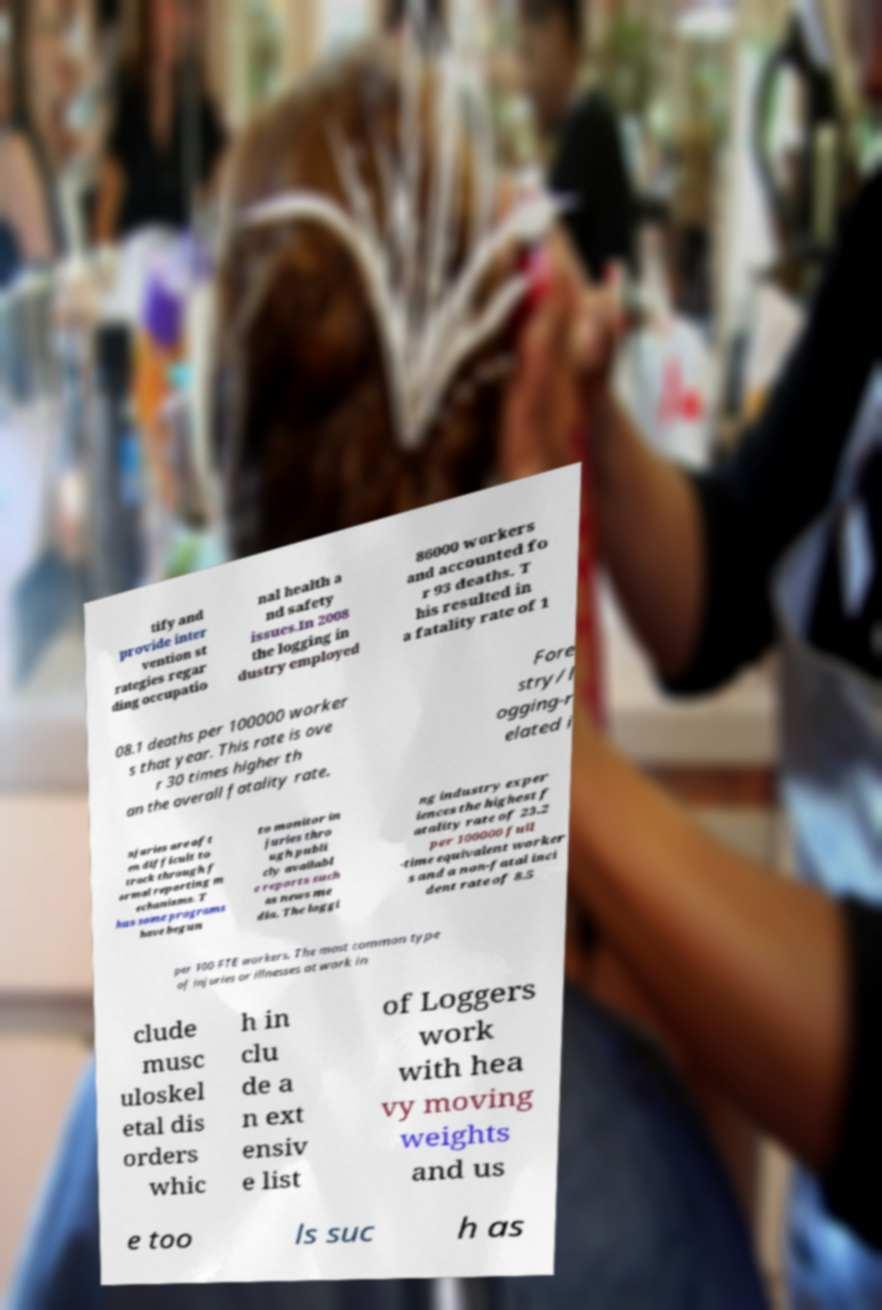There's text embedded in this image that I need extracted. Can you transcribe it verbatim? tify and provide inter vention st rategies regar ding occupatio nal health a nd safety issues.In 2008 the logging in dustry employed 86000 workers and accounted fo r 93 deaths. T his resulted in a fatality rate of 1 08.1 deaths per 100000 worker s that year. This rate is ove r 30 times higher th an the overall fatality rate. Fore stry/l ogging-r elated i njuries are oft en difficult to track through f ormal reporting m echanisms. T hus some programs have begun to monitor in juries thro ugh publi cly availabl e reports such as news me dia. The loggi ng industry exper iences the highest f atality rate of 23.2 per 100000 full -time equivalent worker s and a non-fatal inci dent rate of 8.5 per 100 FTE workers. The most common type of injuries or illnesses at work in clude musc uloskel etal dis orders whic h in clu de a n ext ensiv e list of Loggers work with hea vy moving weights and us e too ls suc h as 